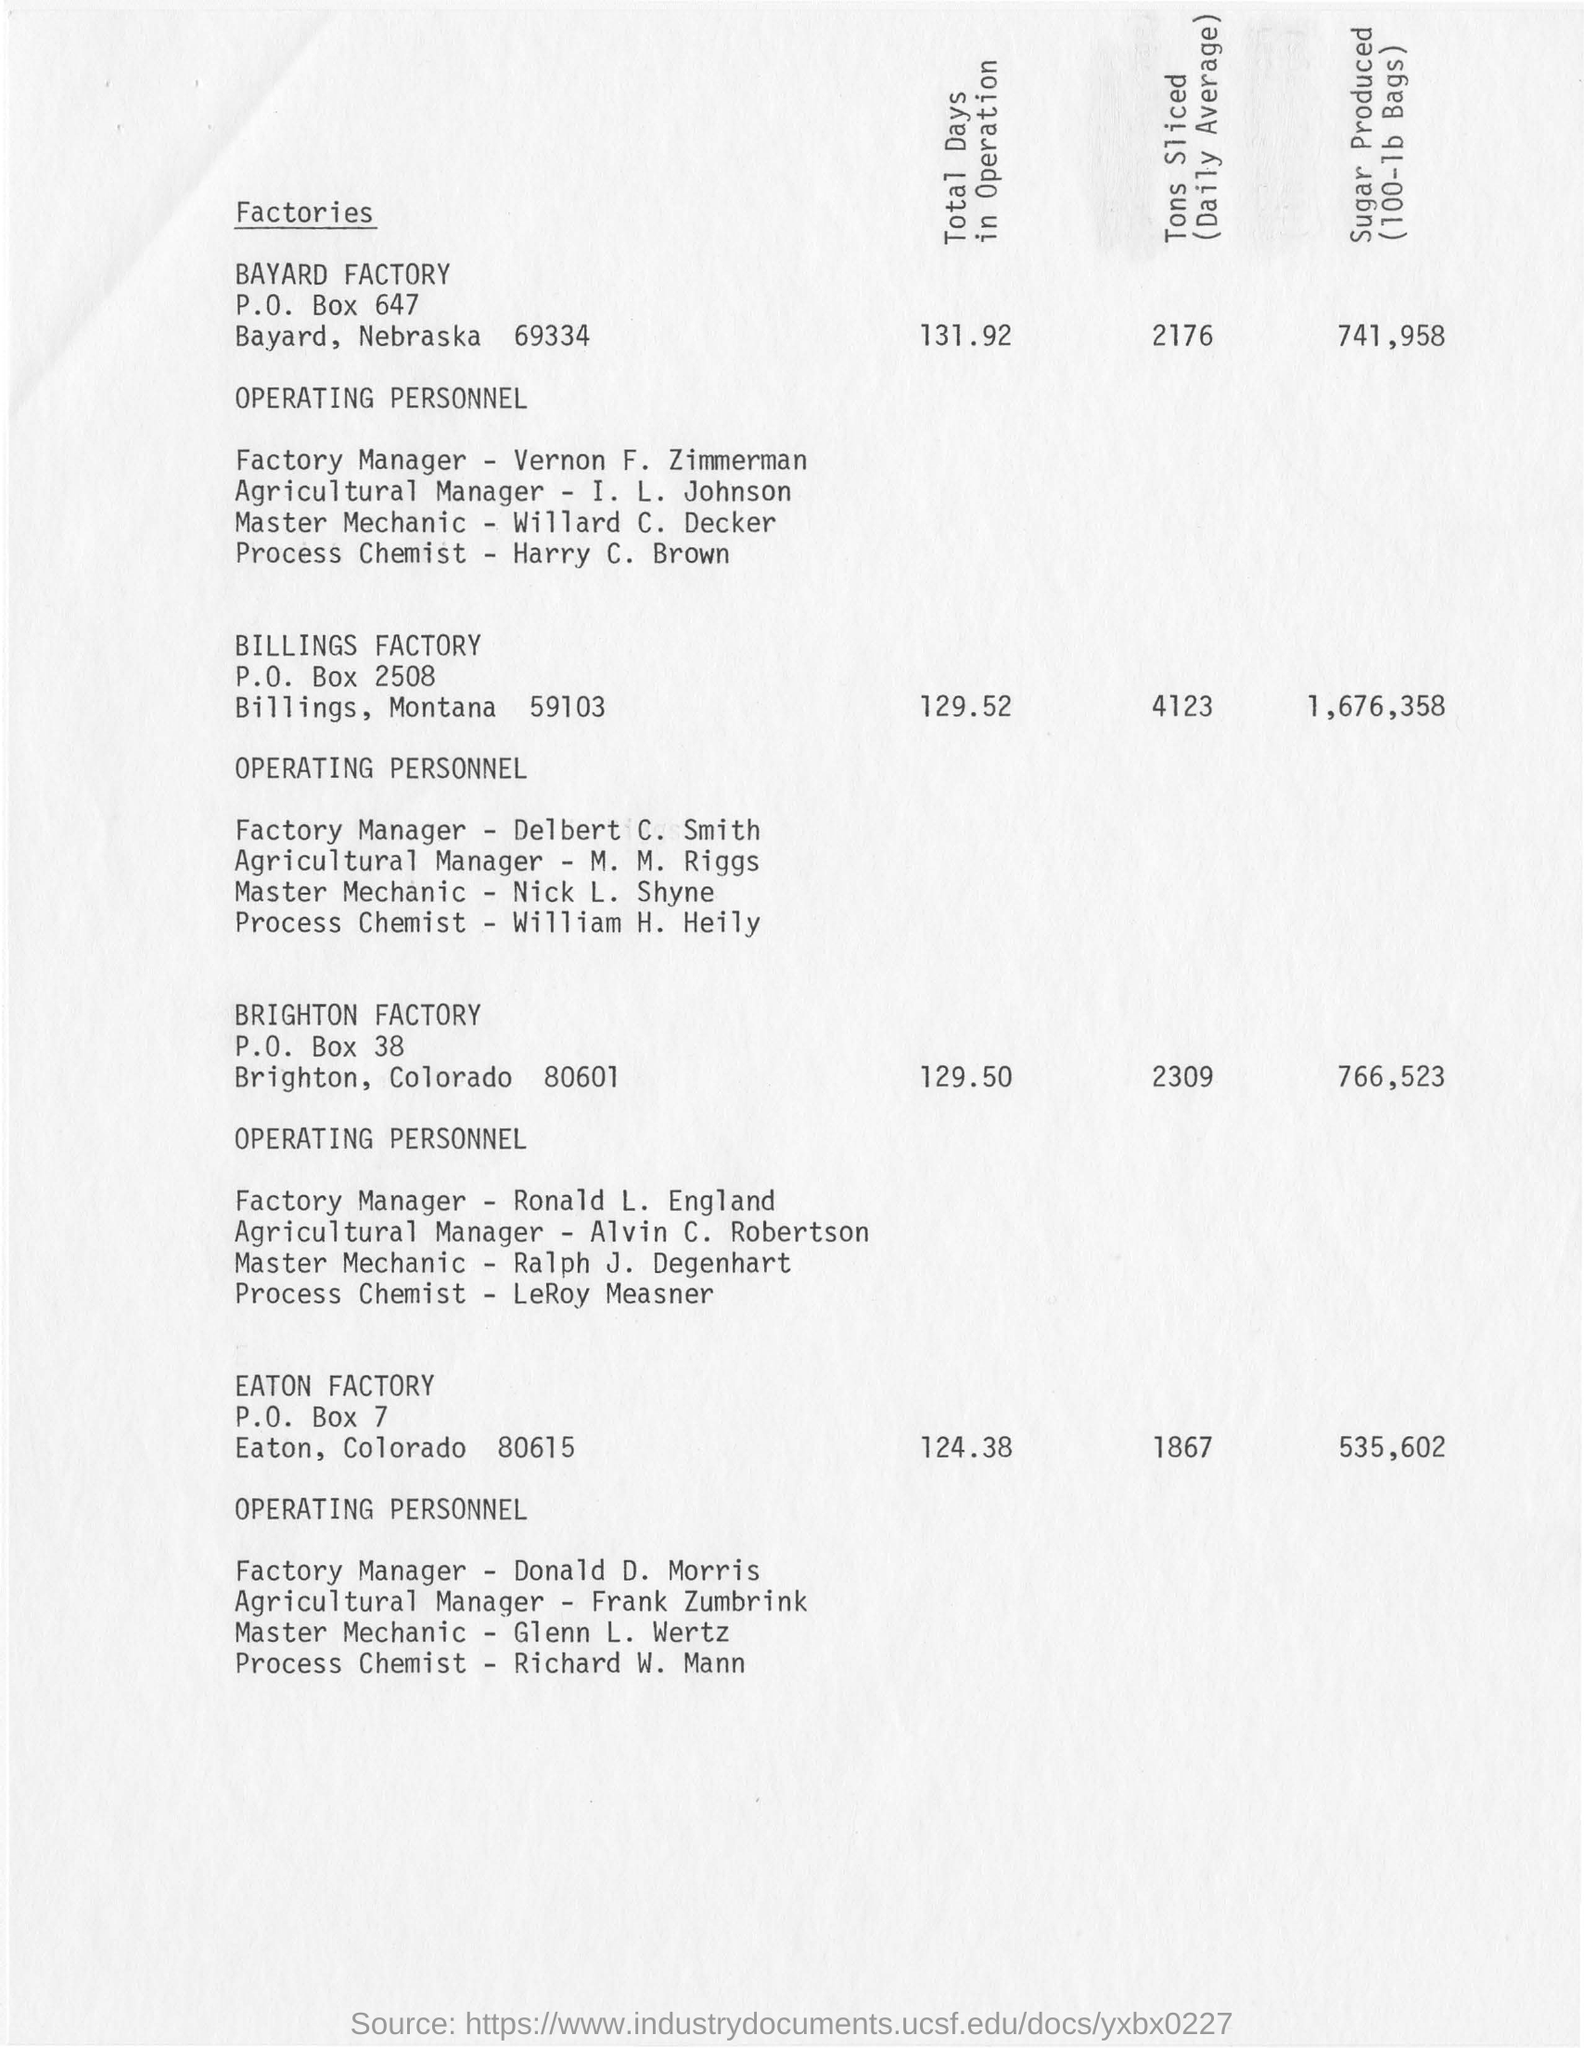Specify some key components in this picture. The factory manager at Eaton Factory is Donald D. Morris. The total number of days in operation for the Brighton factory is 129.50 days. The Eaton Factory is located in Eaton, Colorado. The Billings factory slices an average of 4123 tons of material per year. 